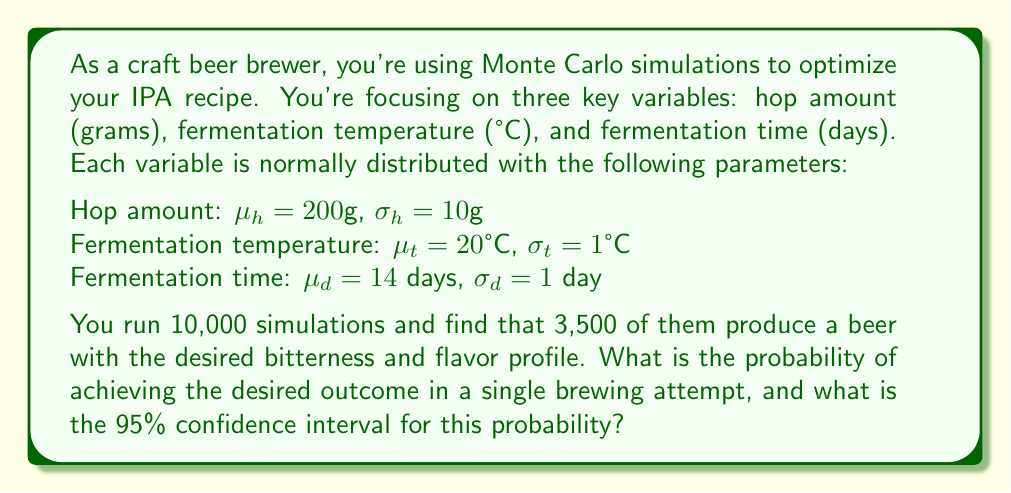Show me your answer to this math problem. To solve this problem, we'll follow these steps:

1. Calculate the point estimate of the probability:
   The point estimate $\hat{p}$ is the number of successful outcomes divided by the total number of simulations.
   $$\hat{p} = \frac{3,500}{10,000} = 0.35$$

2. Calculate the standard error of the estimate:
   The standard error (SE) for a proportion is given by:
   $$SE = \sqrt{\frac{\hat{p}(1-\hat{p})}{n}}$$
   where $n$ is the number of simulations.
   $$SE = \sqrt{\frac{0.35(1-0.35)}{10,000}} = \sqrt{\frac{0.2275}{10,000}} \approx 0.00475$$

3. Determine the critical value for a 95% confidence interval:
   For a 95% CI, we use a z-score of 1.96.

4. Calculate the margin of error:
   Margin of Error (MOE) = Critical value × Standard Error
   $$MOE = 1.96 \times 0.00475 \approx 0.00931$$

5. Compute the confidence interval:
   The 95% CI is given by $(\hat{p} - MOE, \hat{p} + MOE)$
   $$(0.35 - 0.00931, 0.35 + 0.00931)$$
   $$(0.34069, 0.35931)$$

Therefore, we can say with 95% confidence that the true probability of achieving the desired outcome in a single brewing attempt lies between 0.34069 and 0.35931, or approximately between 34.07% and 35.93%.
Answer: Probability: 0.35; 95% CI: (0.34069, 0.35931) 